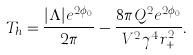Convert formula to latex. <formula><loc_0><loc_0><loc_500><loc_500>T _ { h } = \frac { | \Lambda | e ^ { 2 \phi _ { 0 } } } { 2 \pi } - \frac { 8 \pi Q ^ { 2 } e ^ { 2 \phi _ { 0 } } } { V ^ { 2 } \gamma ^ { 4 } r _ { + } ^ { 2 } } .</formula> 